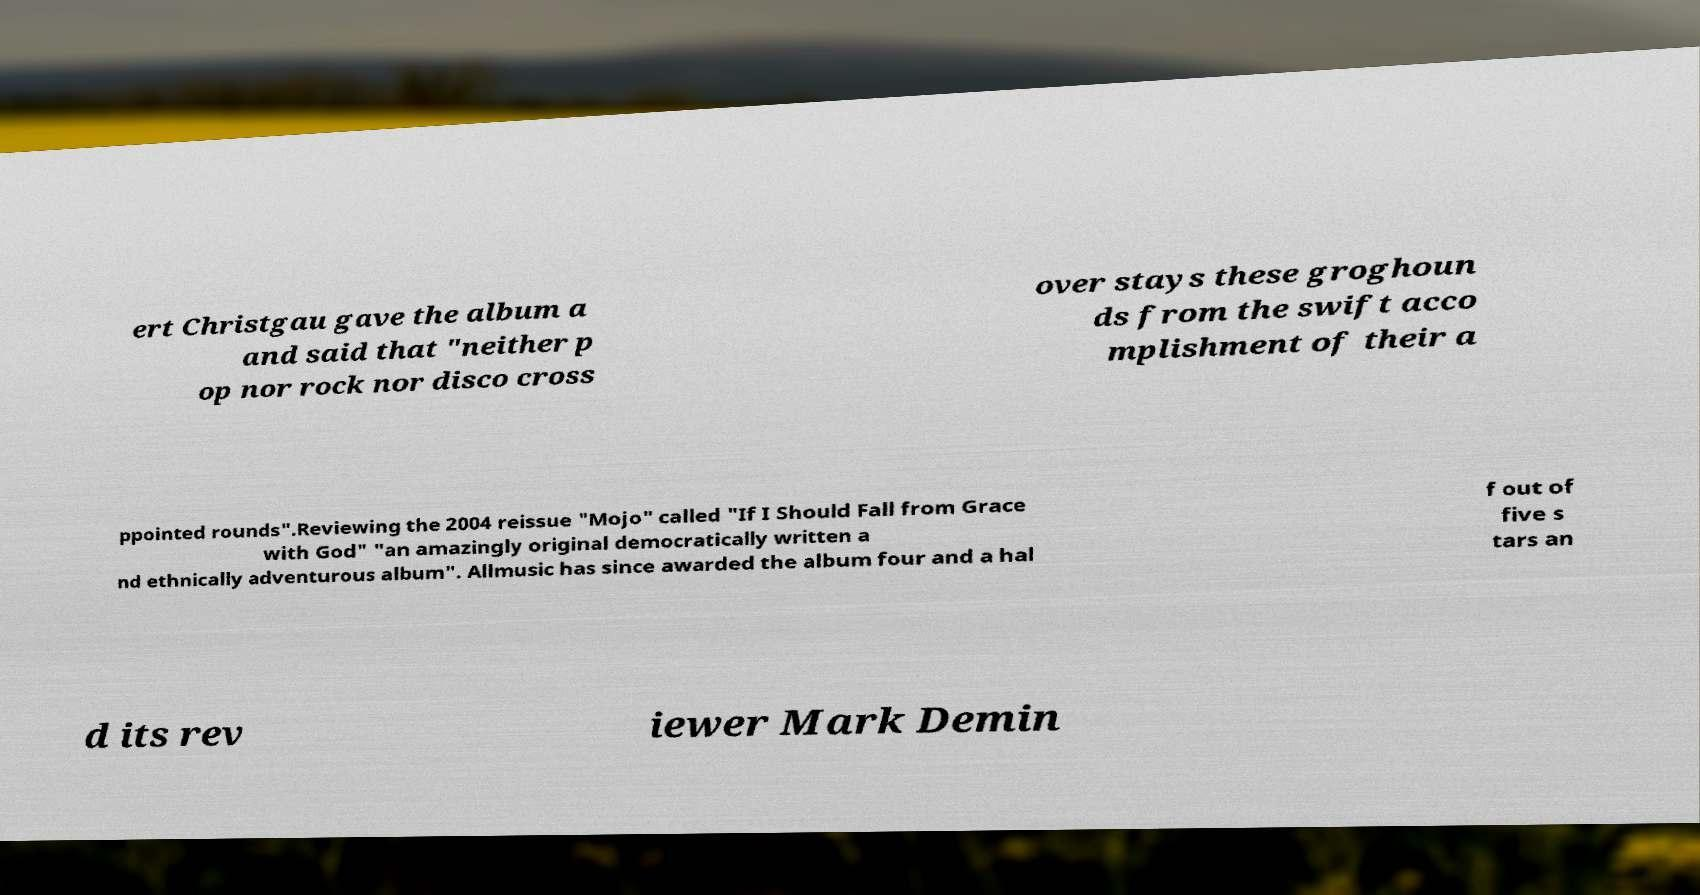What messages or text are displayed in this image? I need them in a readable, typed format. ert Christgau gave the album a and said that "neither p op nor rock nor disco cross over stays these groghoun ds from the swift acco mplishment of their a ppointed rounds".Reviewing the 2004 reissue "Mojo" called "If I Should Fall from Grace with God" "an amazingly original democratically written a nd ethnically adventurous album". Allmusic has since awarded the album four and a hal f out of five s tars an d its rev iewer Mark Demin 